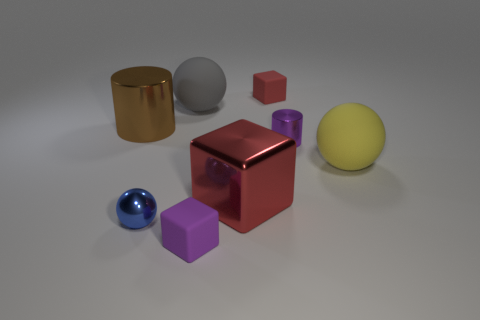There is a small cube that is the same color as the small metal cylinder; what is its material?
Your response must be concise. Rubber. What size is the thing that is the same color as the big metallic cube?
Provide a succinct answer. Small. How many red blocks have the same material as the small blue sphere?
Give a very brief answer. 1. Is there a small purple matte cylinder?
Give a very brief answer. No. There is a matte cube in front of the large shiny cylinder; what size is it?
Give a very brief answer. Small. What number of big metallic cubes are the same color as the big cylinder?
Ensure brevity in your answer.  0. What number of cylinders are either large brown objects or red shiny objects?
Make the answer very short. 1. What is the shape of the big object that is both to the left of the metallic block and to the right of the brown cylinder?
Make the answer very short. Sphere. Is there a gray rubber cylinder of the same size as the gray matte sphere?
Give a very brief answer. No. What number of things are either big spheres on the left side of the red rubber thing or tiny red matte cylinders?
Offer a terse response. 1. 